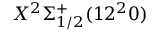Convert formula to latex. <formula><loc_0><loc_0><loc_500><loc_500>X ^ { 2 } \Sigma _ { 1 / 2 } ^ { + } ( 1 2 ^ { 2 } 0 )</formula> 